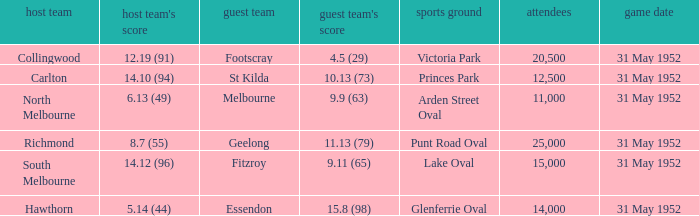Who was the away team at the game at Victoria Park? Footscray. 